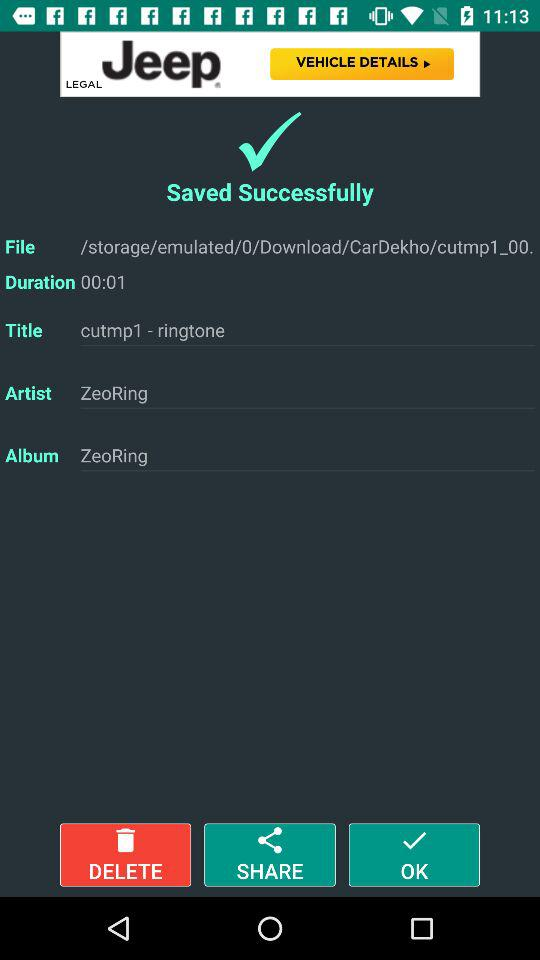Is this file likely to be a song or a smaller sound clip? Given that the duration of the file is only 1 second as listed, it is much too short to be a song. It is more likely to be a short sound clip or notification sound that has been saved as a ringtone, as inferred from the title 'cutmp1 - ringtone.' 